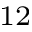<formula> <loc_0><loc_0><loc_500><loc_500>^ { 1 2 }</formula> 